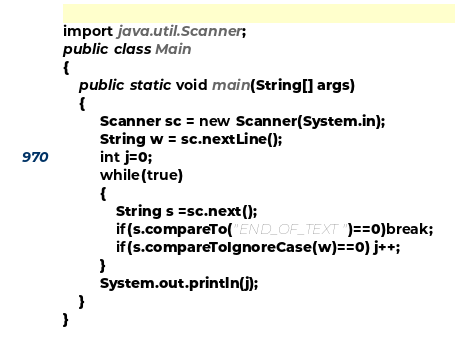Convert code to text. <code><loc_0><loc_0><loc_500><loc_500><_Java_>

import java.util.Scanner;
public class Main
{
    public static void main(String[] args)
    {
         Scanner sc = new Scanner(System.in);
         String w = sc.nextLine();
         int j=0;
         while(true)
         {
             String s =sc.next();
             if(s.compareTo("END_OF_TEXT")==0)break;
             if(s.compareToIgnoreCase(w)==0) j++;
         }
         System.out.println(j);
    }
}
</code> 